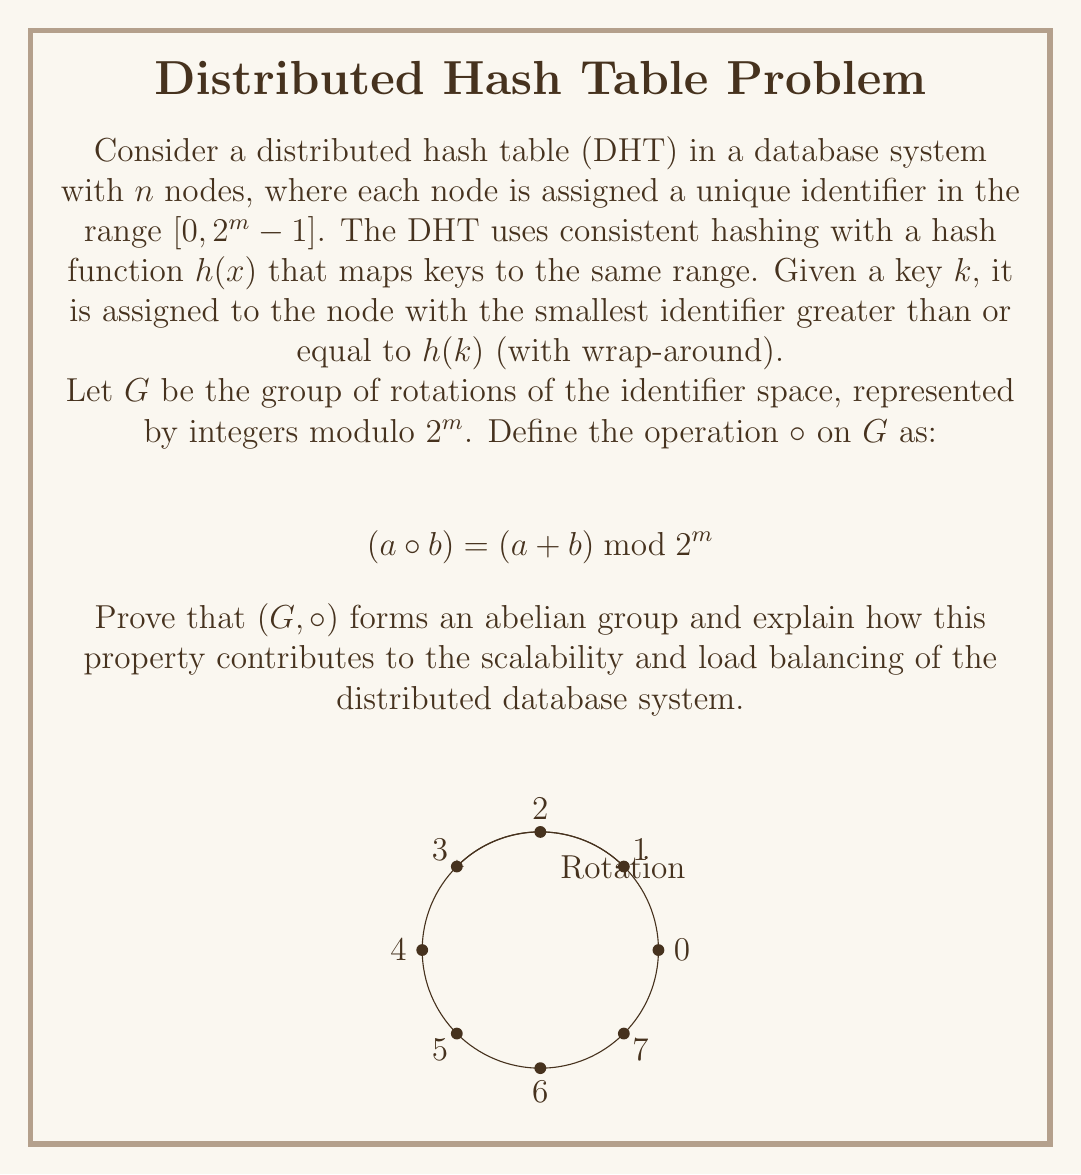Provide a solution to this math problem. To prove that $(G, \circ)$ forms an abelian group, we need to show that it satisfies the four group axioms and the commutativity property:

1. Closure: For any $a, b \in G$, $(a \circ b) = (a + b) \bmod 2^m$ is always in the range $[0, 2^m - 1]$, so it's in $G$.

2. Associativity: For any $a, b, c \in G$:
   $((a \circ b) \circ c) = ((a + b) \bmod 2^m + c) \bmod 2^m$
                          $= (a + b + c) \bmod 2^m$
                          $= (a + (b + c) \bmod 2^m) \bmod 2^m$
                          $= (a \circ (b \circ c))$

3. Identity element: The identity element is $0$, since for any $a \in G$:
   $(a \circ 0) = (0 \circ a) = (a + 0) \bmod 2^m = a$

4. Inverse element: For any $a \in G$, its inverse is $(2^m - a) \bmod 2^m$, since:
   $(a \circ (2^m - a)) = (a + 2^m - a) \bmod 2^m = 2^m \bmod 2^m = 0$

5. Commutativity: For any $a, b \in G$:
   $(a \circ b) = (a + b) \bmod 2^m = (b + a) \bmod 2^m = (b \circ a)$

Therefore, $(G, \circ)$ forms an abelian group.

This algebraic property contributes to the scalability and load balancing of the distributed database system in several ways:

1. Uniform distribution: The group structure ensures that keys are uniformly distributed across the nodes, promoting load balancing.

2. Scalability: When adding or removing nodes, only a fraction of keys need to be reassigned, facilitating easy scaling.

3. Fault tolerance: The circular nature of the group allows for automatic key reassignment when nodes fail.

4. Decentralization: The group structure allows any node to route requests efficiently without centralized coordination.

5. Consistency: The abelian property ensures that the order of node additions or removals doesn't affect the final key distribution.

These properties collectively enable the distributed hash table to maintain efficiency and balance as the system scales, nodes join or leave, and in the presence of failures.
Answer: $(G, \circ)$ is an abelian group, enhancing scalability and load balancing through uniform key distribution, efficient node addition/removal, fault tolerance, decentralized routing, and consistent key assignment. 